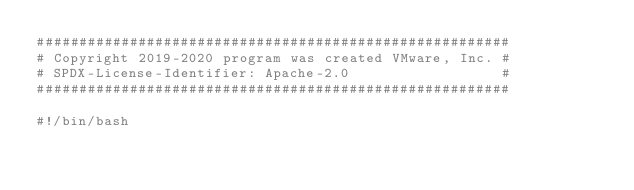<code> <loc_0><loc_0><loc_500><loc_500><_Bash_>########################################################
# Copyright 2019-2020 program was created VMware, Inc. #
# SPDX-License-Identifier: Apache-2.0                  #
########################################################

#!/bin/bash
</code> 